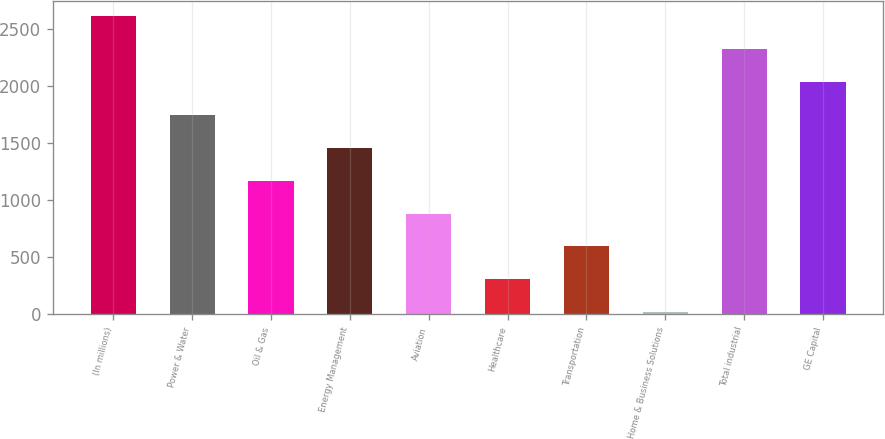Convert chart. <chart><loc_0><loc_0><loc_500><loc_500><bar_chart><fcel>(In millions)<fcel>Power & Water<fcel>Oil & Gas<fcel>Energy Management<fcel>Aviation<fcel>Healthcare<fcel>Transportation<fcel>Home & Business Solutions<fcel>Total industrial<fcel>GE Capital<nl><fcel>2613.6<fcel>1748.4<fcel>1171.6<fcel>1460<fcel>883.2<fcel>306.4<fcel>594.8<fcel>18<fcel>2325.2<fcel>2036.8<nl></chart> 